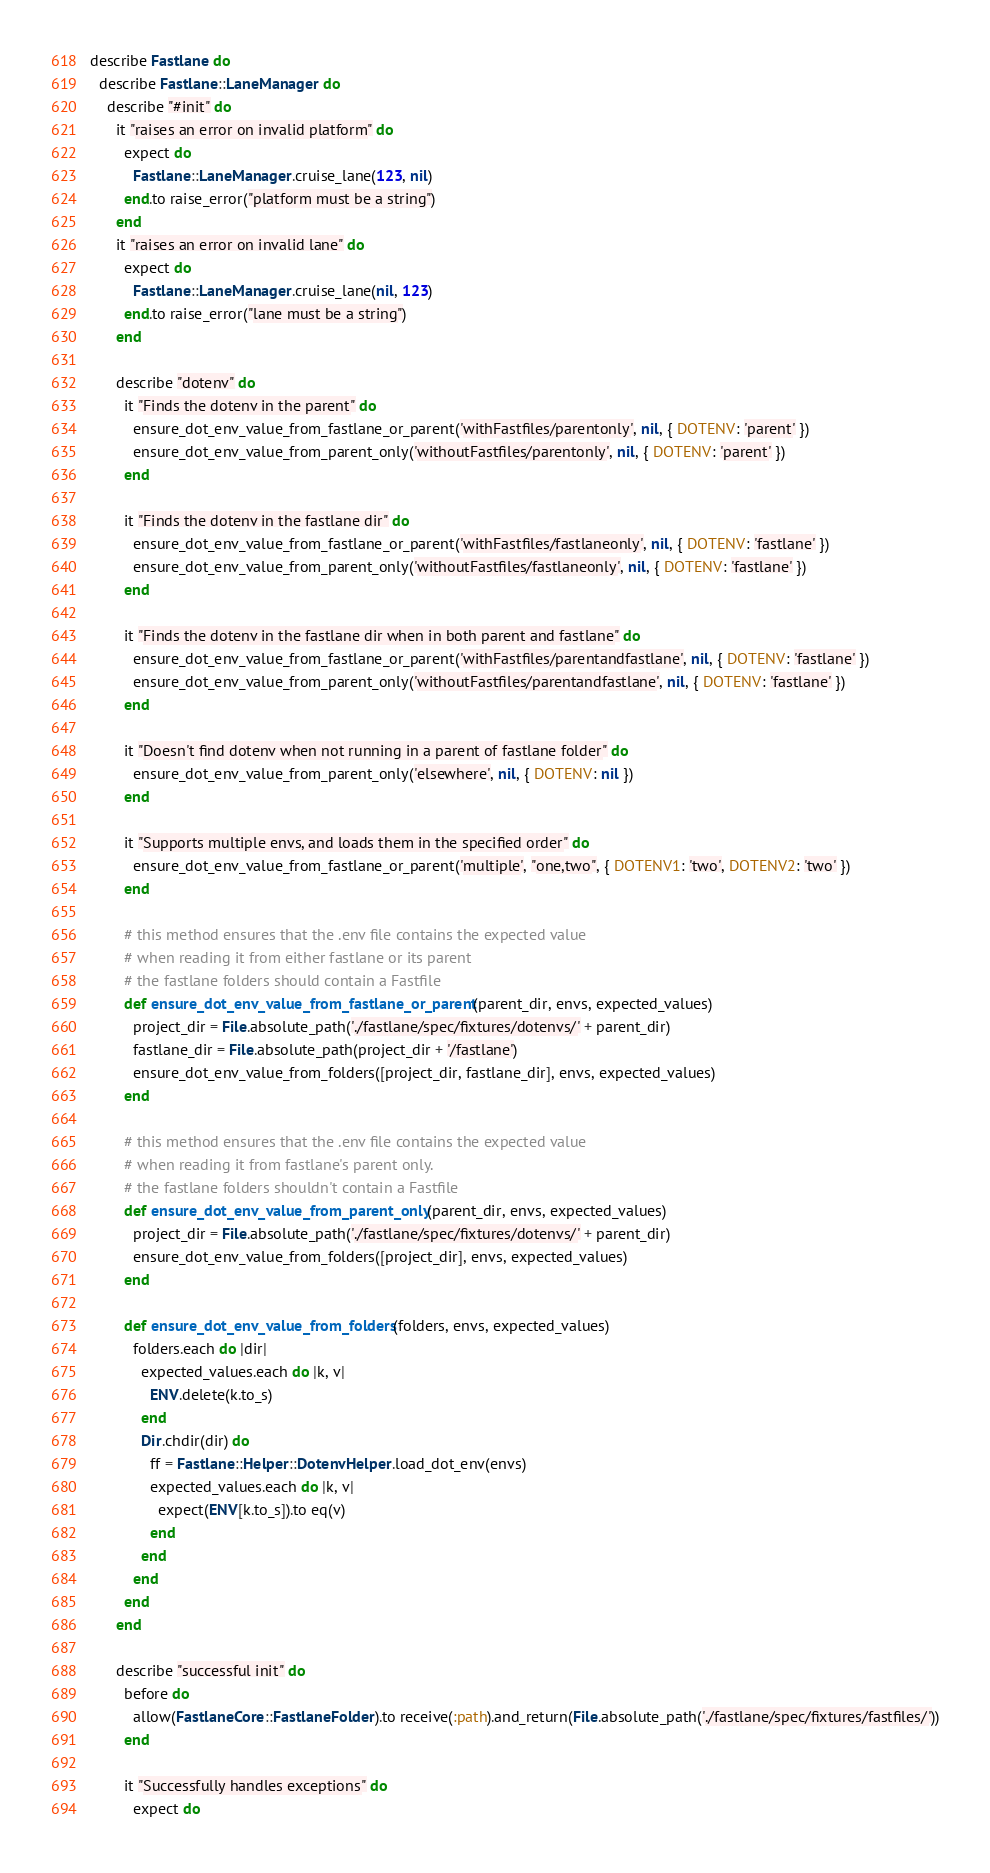Convert code to text. <code><loc_0><loc_0><loc_500><loc_500><_Ruby_>describe Fastlane do
  describe Fastlane::LaneManager do
    describe "#init" do
      it "raises an error on invalid platform" do
        expect do
          Fastlane::LaneManager.cruise_lane(123, nil)
        end.to raise_error("platform must be a string")
      end
      it "raises an error on invalid lane" do
        expect do
          Fastlane::LaneManager.cruise_lane(nil, 123)
        end.to raise_error("lane must be a string")
      end

      describe "dotenv" do
        it "Finds the dotenv in the parent" do
          ensure_dot_env_value_from_fastlane_or_parent('withFastfiles/parentonly', nil, { DOTENV: 'parent' })
          ensure_dot_env_value_from_parent_only('withoutFastfiles/parentonly', nil, { DOTENV: 'parent' })
        end

        it "Finds the dotenv in the fastlane dir" do
          ensure_dot_env_value_from_fastlane_or_parent('withFastfiles/fastlaneonly', nil, { DOTENV: 'fastlane' })
          ensure_dot_env_value_from_parent_only('withoutFastfiles/fastlaneonly', nil, { DOTENV: 'fastlane' })
        end

        it "Finds the dotenv in the fastlane dir when in both parent and fastlane" do
          ensure_dot_env_value_from_fastlane_or_parent('withFastfiles/parentandfastlane', nil, { DOTENV: 'fastlane' })
          ensure_dot_env_value_from_parent_only('withoutFastfiles/parentandfastlane', nil, { DOTENV: 'fastlane' })
        end

        it "Doesn't find dotenv when not running in a parent of fastlane folder" do
          ensure_dot_env_value_from_parent_only('elsewhere', nil, { DOTENV: nil })
        end

        it "Supports multiple envs, and loads them in the specified order" do
          ensure_dot_env_value_from_fastlane_or_parent('multiple', "one,two", { DOTENV1: 'two', DOTENV2: 'two' })
        end

        # this method ensures that the .env file contains the expected value
        # when reading it from either fastlane or its parent
        # the fastlane folders should contain a Fastfile
        def ensure_dot_env_value_from_fastlane_or_parent(parent_dir, envs, expected_values)
          project_dir = File.absolute_path('./fastlane/spec/fixtures/dotenvs/' + parent_dir)
          fastlane_dir = File.absolute_path(project_dir + '/fastlane')
          ensure_dot_env_value_from_folders([project_dir, fastlane_dir], envs, expected_values)
        end

        # this method ensures that the .env file contains the expected value
        # when reading it from fastlane's parent only.
        # the fastlane folders shouldn't contain a Fastfile
        def ensure_dot_env_value_from_parent_only(parent_dir, envs, expected_values)
          project_dir = File.absolute_path('./fastlane/spec/fixtures/dotenvs/' + parent_dir)
          ensure_dot_env_value_from_folders([project_dir], envs, expected_values)
        end

        def ensure_dot_env_value_from_folders(folders, envs, expected_values)
          folders.each do |dir|
            expected_values.each do |k, v|
              ENV.delete(k.to_s)
            end
            Dir.chdir(dir) do
              ff = Fastlane::Helper::DotenvHelper.load_dot_env(envs)
              expected_values.each do |k, v|
                expect(ENV[k.to_s]).to eq(v)
              end
            end
          end
        end
      end

      describe "successful init" do
        before do
          allow(FastlaneCore::FastlaneFolder).to receive(:path).and_return(File.absolute_path('./fastlane/spec/fixtures/fastfiles/'))
        end

        it "Successfully handles exceptions" do
          expect do</code> 